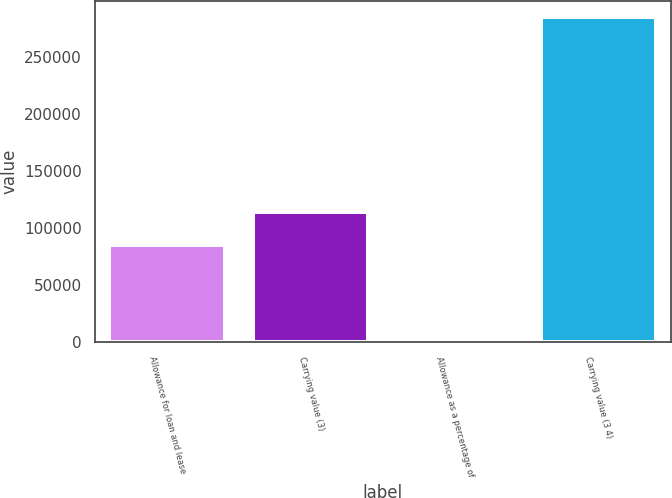Convert chart to OTSL. <chart><loc_0><loc_0><loc_500><loc_500><bar_chart><fcel>Allowance for loan and lease<fcel>Carrying value (3)<fcel>Allowance as a percentage of<fcel>Carrying value (3 4)<nl><fcel>85505.7<fcel>114007<fcel>1.68<fcel>285015<nl></chart> 